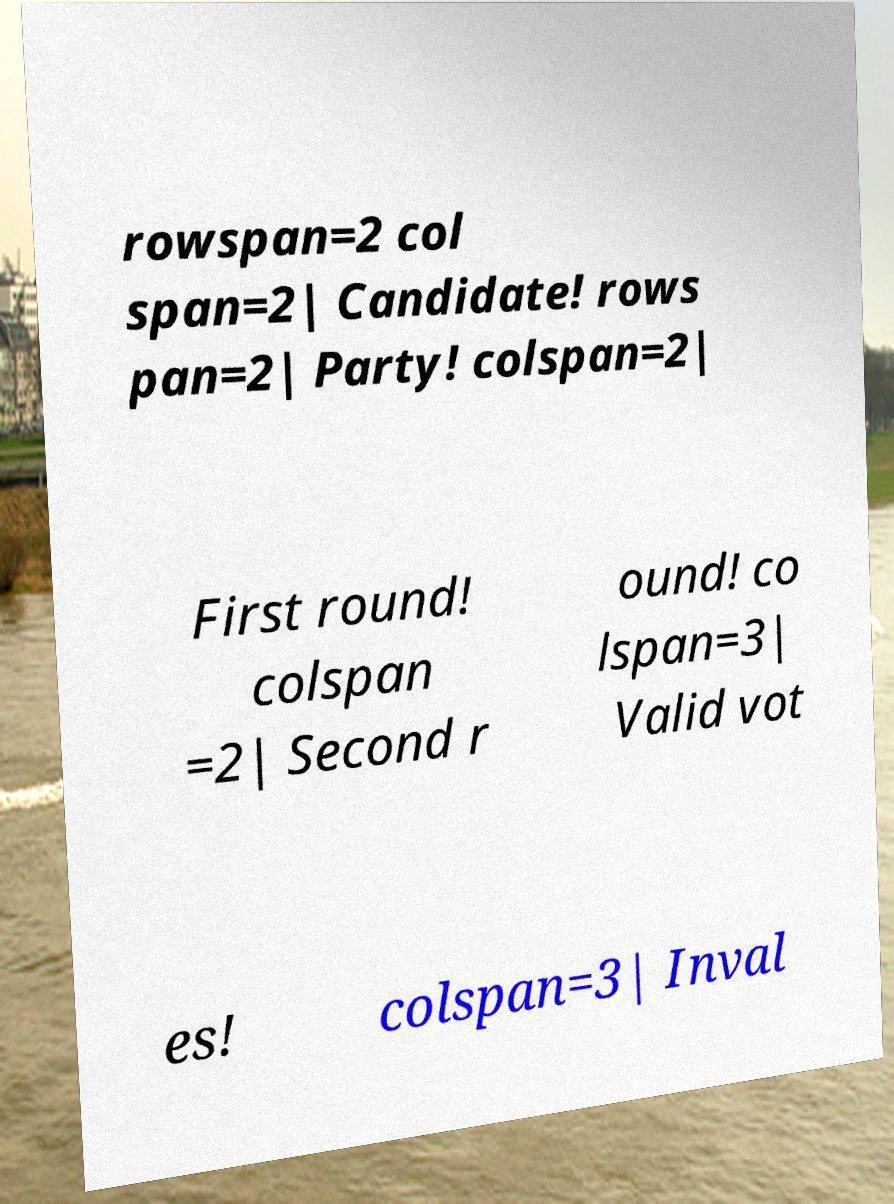What messages or text are displayed in this image? I need them in a readable, typed format. rowspan=2 col span=2| Candidate! rows pan=2| Party! colspan=2| First round! colspan =2| Second r ound! co lspan=3| Valid vot es! colspan=3| Inval 